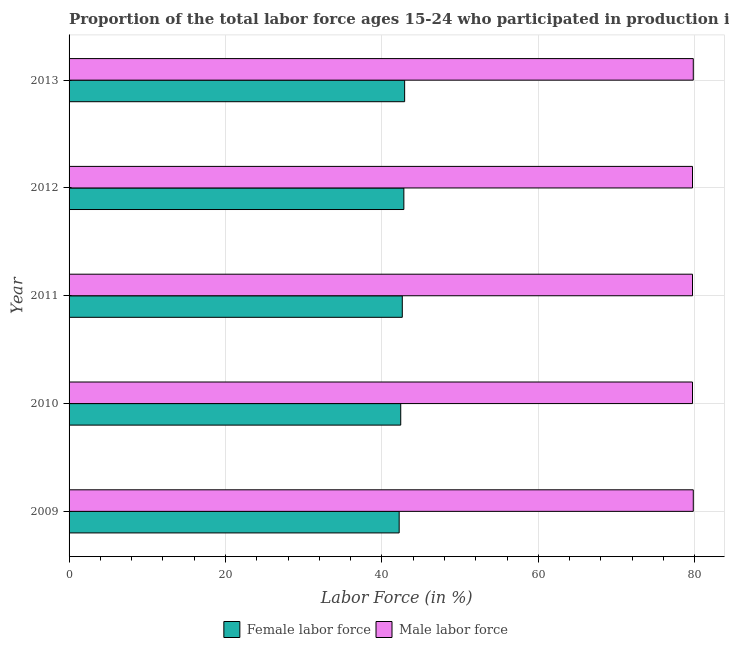How many different coloured bars are there?
Your answer should be very brief. 2. Are the number of bars per tick equal to the number of legend labels?
Make the answer very short. Yes. Are the number of bars on each tick of the Y-axis equal?
Provide a short and direct response. Yes. How many bars are there on the 1st tick from the bottom?
Keep it short and to the point. 2. What is the label of the 5th group of bars from the top?
Give a very brief answer. 2009. What is the percentage of female labor force in 2010?
Make the answer very short. 42.4. Across all years, what is the maximum percentage of female labor force?
Give a very brief answer. 42.9. Across all years, what is the minimum percentage of female labor force?
Your response must be concise. 42.2. In which year was the percentage of male labour force maximum?
Offer a very short reply. 2009. In which year was the percentage of male labour force minimum?
Give a very brief answer. 2010. What is the total percentage of male labour force in the graph?
Keep it short and to the point. 398.7. What is the difference between the percentage of female labor force in 2009 and that in 2013?
Give a very brief answer. -0.7. What is the difference between the percentage of female labor force in 2011 and the percentage of male labour force in 2010?
Your answer should be very brief. -37.1. What is the average percentage of male labour force per year?
Give a very brief answer. 79.74. In the year 2013, what is the difference between the percentage of male labour force and percentage of female labor force?
Your answer should be very brief. 36.9. In how many years, is the percentage of male labour force greater than 12 %?
Your answer should be very brief. 5. Is the difference between the percentage of female labor force in 2009 and 2010 greater than the difference between the percentage of male labour force in 2009 and 2010?
Ensure brevity in your answer.  No. What is the difference between the highest and the second highest percentage of male labour force?
Ensure brevity in your answer.  0. In how many years, is the percentage of male labour force greater than the average percentage of male labour force taken over all years?
Keep it short and to the point. 2. What does the 1st bar from the top in 2009 represents?
Your response must be concise. Male labor force. What does the 1st bar from the bottom in 2013 represents?
Your answer should be compact. Female labor force. How many years are there in the graph?
Your answer should be compact. 5. Are the values on the major ticks of X-axis written in scientific E-notation?
Ensure brevity in your answer.  No. Does the graph contain grids?
Ensure brevity in your answer.  Yes. How many legend labels are there?
Provide a short and direct response. 2. What is the title of the graph?
Your response must be concise. Proportion of the total labor force ages 15-24 who participated in production in Guatemala. What is the label or title of the X-axis?
Your answer should be very brief. Labor Force (in %). What is the Labor Force (in %) of Female labor force in 2009?
Ensure brevity in your answer.  42.2. What is the Labor Force (in %) of Male labor force in 2009?
Your answer should be very brief. 79.8. What is the Labor Force (in %) in Female labor force in 2010?
Provide a short and direct response. 42.4. What is the Labor Force (in %) of Male labor force in 2010?
Give a very brief answer. 79.7. What is the Labor Force (in %) of Female labor force in 2011?
Give a very brief answer. 42.6. What is the Labor Force (in %) in Male labor force in 2011?
Your answer should be compact. 79.7. What is the Labor Force (in %) in Female labor force in 2012?
Offer a very short reply. 42.8. What is the Labor Force (in %) of Male labor force in 2012?
Keep it short and to the point. 79.7. What is the Labor Force (in %) in Female labor force in 2013?
Provide a succinct answer. 42.9. What is the Labor Force (in %) of Male labor force in 2013?
Provide a short and direct response. 79.8. Across all years, what is the maximum Labor Force (in %) in Female labor force?
Offer a very short reply. 42.9. Across all years, what is the maximum Labor Force (in %) of Male labor force?
Make the answer very short. 79.8. Across all years, what is the minimum Labor Force (in %) in Female labor force?
Your answer should be very brief. 42.2. Across all years, what is the minimum Labor Force (in %) of Male labor force?
Your response must be concise. 79.7. What is the total Labor Force (in %) in Female labor force in the graph?
Provide a short and direct response. 212.9. What is the total Labor Force (in %) of Male labor force in the graph?
Make the answer very short. 398.7. What is the difference between the Labor Force (in %) in Male labor force in 2009 and that in 2010?
Your answer should be very brief. 0.1. What is the difference between the Labor Force (in %) of Female labor force in 2009 and that in 2011?
Ensure brevity in your answer.  -0.4. What is the difference between the Labor Force (in %) in Female labor force in 2009 and that in 2012?
Offer a very short reply. -0.6. What is the difference between the Labor Force (in %) in Male labor force in 2009 and that in 2012?
Your response must be concise. 0.1. What is the difference between the Labor Force (in %) of Female labor force in 2010 and that in 2011?
Your answer should be very brief. -0.2. What is the difference between the Labor Force (in %) of Male labor force in 2010 and that in 2012?
Your answer should be very brief. 0. What is the difference between the Labor Force (in %) of Female labor force in 2010 and that in 2013?
Keep it short and to the point. -0.5. What is the difference between the Labor Force (in %) of Female labor force in 2011 and that in 2012?
Make the answer very short. -0.2. What is the difference between the Labor Force (in %) in Male labor force in 2011 and that in 2012?
Offer a terse response. 0. What is the difference between the Labor Force (in %) in Female labor force in 2011 and that in 2013?
Give a very brief answer. -0.3. What is the difference between the Labor Force (in %) in Male labor force in 2011 and that in 2013?
Offer a terse response. -0.1. What is the difference between the Labor Force (in %) in Female labor force in 2012 and that in 2013?
Your answer should be very brief. -0.1. What is the difference between the Labor Force (in %) of Female labor force in 2009 and the Labor Force (in %) of Male labor force in 2010?
Keep it short and to the point. -37.5. What is the difference between the Labor Force (in %) of Female labor force in 2009 and the Labor Force (in %) of Male labor force in 2011?
Provide a succinct answer. -37.5. What is the difference between the Labor Force (in %) of Female labor force in 2009 and the Labor Force (in %) of Male labor force in 2012?
Offer a very short reply. -37.5. What is the difference between the Labor Force (in %) in Female labor force in 2009 and the Labor Force (in %) in Male labor force in 2013?
Keep it short and to the point. -37.6. What is the difference between the Labor Force (in %) in Female labor force in 2010 and the Labor Force (in %) in Male labor force in 2011?
Your response must be concise. -37.3. What is the difference between the Labor Force (in %) of Female labor force in 2010 and the Labor Force (in %) of Male labor force in 2012?
Ensure brevity in your answer.  -37.3. What is the difference between the Labor Force (in %) in Female labor force in 2010 and the Labor Force (in %) in Male labor force in 2013?
Offer a terse response. -37.4. What is the difference between the Labor Force (in %) of Female labor force in 2011 and the Labor Force (in %) of Male labor force in 2012?
Your answer should be very brief. -37.1. What is the difference between the Labor Force (in %) in Female labor force in 2011 and the Labor Force (in %) in Male labor force in 2013?
Make the answer very short. -37.2. What is the difference between the Labor Force (in %) in Female labor force in 2012 and the Labor Force (in %) in Male labor force in 2013?
Offer a very short reply. -37. What is the average Labor Force (in %) of Female labor force per year?
Provide a short and direct response. 42.58. What is the average Labor Force (in %) of Male labor force per year?
Your answer should be compact. 79.74. In the year 2009, what is the difference between the Labor Force (in %) in Female labor force and Labor Force (in %) in Male labor force?
Provide a succinct answer. -37.6. In the year 2010, what is the difference between the Labor Force (in %) in Female labor force and Labor Force (in %) in Male labor force?
Your answer should be compact. -37.3. In the year 2011, what is the difference between the Labor Force (in %) in Female labor force and Labor Force (in %) in Male labor force?
Keep it short and to the point. -37.1. In the year 2012, what is the difference between the Labor Force (in %) in Female labor force and Labor Force (in %) in Male labor force?
Provide a short and direct response. -36.9. In the year 2013, what is the difference between the Labor Force (in %) of Female labor force and Labor Force (in %) of Male labor force?
Offer a very short reply. -36.9. What is the ratio of the Labor Force (in %) of Female labor force in 2009 to that in 2011?
Offer a terse response. 0.99. What is the ratio of the Labor Force (in %) in Male labor force in 2009 to that in 2011?
Offer a very short reply. 1. What is the ratio of the Labor Force (in %) of Female labor force in 2009 to that in 2012?
Ensure brevity in your answer.  0.99. What is the ratio of the Labor Force (in %) of Male labor force in 2009 to that in 2012?
Provide a short and direct response. 1. What is the ratio of the Labor Force (in %) of Female labor force in 2009 to that in 2013?
Offer a very short reply. 0.98. What is the ratio of the Labor Force (in %) of Female labor force in 2010 to that in 2011?
Give a very brief answer. 1. What is the ratio of the Labor Force (in %) of Female labor force in 2010 to that in 2013?
Your answer should be very brief. 0.99. What is the ratio of the Labor Force (in %) of Female labor force in 2011 to that in 2012?
Keep it short and to the point. 1. What is the ratio of the Labor Force (in %) in Male labor force in 2011 to that in 2012?
Your response must be concise. 1. What is the ratio of the Labor Force (in %) in Female labor force in 2011 to that in 2013?
Give a very brief answer. 0.99. What is the ratio of the Labor Force (in %) of Male labor force in 2011 to that in 2013?
Make the answer very short. 1. What is the ratio of the Labor Force (in %) of Male labor force in 2012 to that in 2013?
Give a very brief answer. 1. 